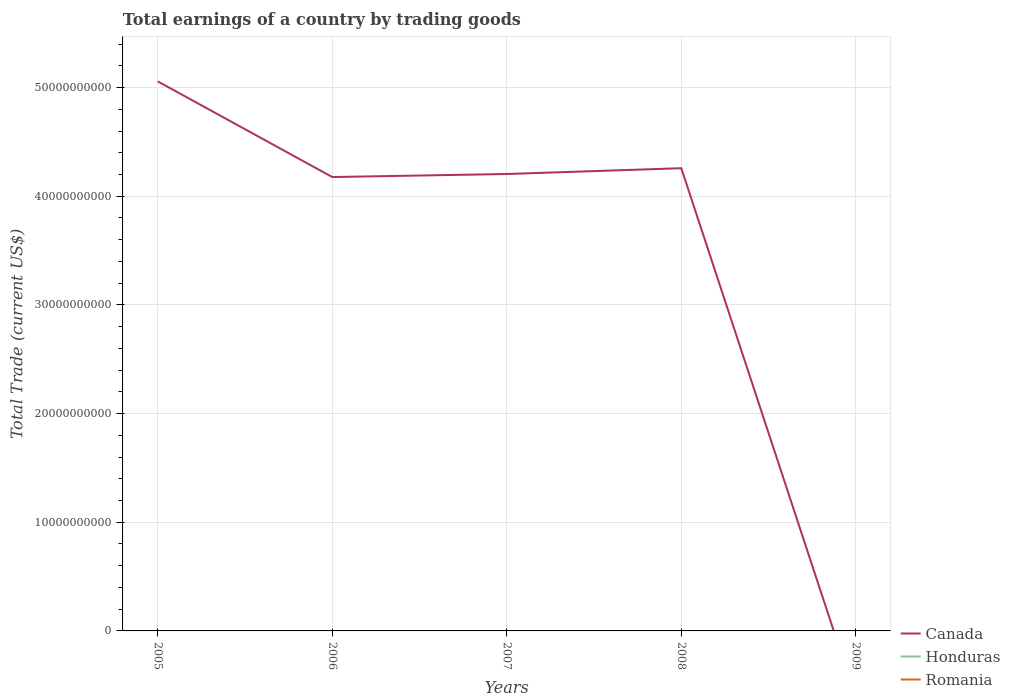How many different coloured lines are there?
Keep it short and to the point. 1. Is the number of lines equal to the number of legend labels?
Your answer should be compact. No. Across all years, what is the maximum total earnings in Honduras?
Give a very brief answer. 0. What is the total total earnings in Canada in the graph?
Provide a short and direct response. 8.80e+09. What is the difference between the highest and the second highest total earnings in Canada?
Make the answer very short. 5.06e+1. What is the difference between the highest and the lowest total earnings in Romania?
Offer a terse response. 0. How many years are there in the graph?
Your answer should be very brief. 5. What is the difference between two consecutive major ticks on the Y-axis?
Your answer should be very brief. 1.00e+1. Are the values on the major ticks of Y-axis written in scientific E-notation?
Ensure brevity in your answer.  No. Does the graph contain grids?
Offer a terse response. Yes. How many legend labels are there?
Your answer should be compact. 3. How are the legend labels stacked?
Offer a very short reply. Vertical. What is the title of the graph?
Offer a very short reply. Total earnings of a country by trading goods. Does "Haiti" appear as one of the legend labels in the graph?
Give a very brief answer. No. What is the label or title of the X-axis?
Keep it short and to the point. Years. What is the label or title of the Y-axis?
Offer a terse response. Total Trade (current US$). What is the Total Trade (current US$) in Canada in 2005?
Give a very brief answer. 5.06e+1. What is the Total Trade (current US$) of Canada in 2006?
Make the answer very short. 4.18e+1. What is the Total Trade (current US$) in Honduras in 2006?
Give a very brief answer. 0. What is the Total Trade (current US$) of Canada in 2007?
Offer a very short reply. 4.20e+1. What is the Total Trade (current US$) in Honduras in 2007?
Give a very brief answer. 0. What is the Total Trade (current US$) of Romania in 2007?
Give a very brief answer. 0. What is the Total Trade (current US$) of Canada in 2008?
Give a very brief answer. 4.26e+1. What is the Total Trade (current US$) in Romania in 2009?
Give a very brief answer. 0. Across all years, what is the maximum Total Trade (current US$) of Canada?
Offer a terse response. 5.06e+1. What is the total Total Trade (current US$) in Canada in the graph?
Provide a succinct answer. 1.77e+11. What is the difference between the Total Trade (current US$) of Canada in 2005 and that in 2006?
Ensure brevity in your answer.  8.80e+09. What is the difference between the Total Trade (current US$) of Canada in 2005 and that in 2007?
Ensure brevity in your answer.  8.52e+09. What is the difference between the Total Trade (current US$) of Canada in 2005 and that in 2008?
Keep it short and to the point. 7.99e+09. What is the difference between the Total Trade (current US$) of Canada in 2006 and that in 2007?
Offer a terse response. -2.80e+08. What is the difference between the Total Trade (current US$) of Canada in 2006 and that in 2008?
Keep it short and to the point. -8.14e+08. What is the difference between the Total Trade (current US$) of Canada in 2007 and that in 2008?
Keep it short and to the point. -5.34e+08. What is the average Total Trade (current US$) in Canada per year?
Provide a short and direct response. 3.54e+1. What is the average Total Trade (current US$) of Romania per year?
Your answer should be compact. 0. What is the ratio of the Total Trade (current US$) in Canada in 2005 to that in 2006?
Your answer should be compact. 1.21. What is the ratio of the Total Trade (current US$) of Canada in 2005 to that in 2007?
Provide a short and direct response. 1.2. What is the ratio of the Total Trade (current US$) of Canada in 2005 to that in 2008?
Your answer should be very brief. 1.19. What is the ratio of the Total Trade (current US$) in Canada in 2006 to that in 2008?
Provide a succinct answer. 0.98. What is the ratio of the Total Trade (current US$) in Canada in 2007 to that in 2008?
Your answer should be compact. 0.99. What is the difference between the highest and the second highest Total Trade (current US$) in Canada?
Keep it short and to the point. 7.99e+09. What is the difference between the highest and the lowest Total Trade (current US$) of Canada?
Your response must be concise. 5.06e+1. 